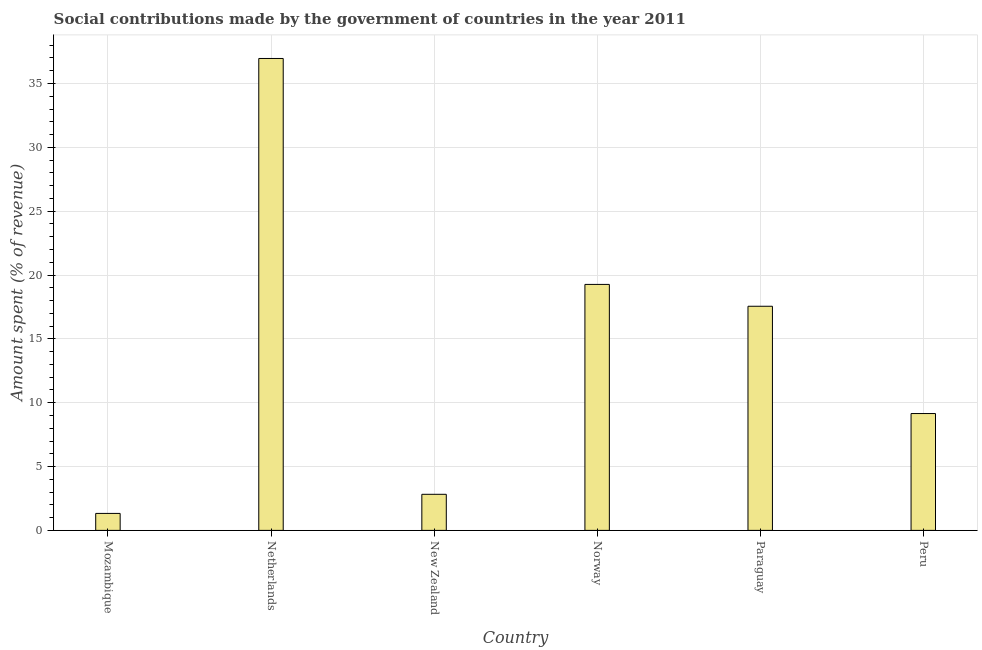What is the title of the graph?
Your answer should be very brief. Social contributions made by the government of countries in the year 2011. What is the label or title of the X-axis?
Your answer should be very brief. Country. What is the label or title of the Y-axis?
Keep it short and to the point. Amount spent (% of revenue). What is the amount spent in making social contributions in Netherlands?
Give a very brief answer. 36.96. Across all countries, what is the maximum amount spent in making social contributions?
Offer a terse response. 36.96. Across all countries, what is the minimum amount spent in making social contributions?
Provide a short and direct response. 1.33. In which country was the amount spent in making social contributions minimum?
Give a very brief answer. Mozambique. What is the sum of the amount spent in making social contributions?
Provide a short and direct response. 87.09. What is the difference between the amount spent in making social contributions in New Zealand and Norway?
Your answer should be very brief. -16.44. What is the average amount spent in making social contributions per country?
Offer a terse response. 14.52. What is the median amount spent in making social contributions?
Keep it short and to the point. 13.35. In how many countries, is the amount spent in making social contributions greater than 3 %?
Provide a succinct answer. 4. What is the ratio of the amount spent in making social contributions in Mozambique to that in Peru?
Make the answer very short. 0.14. Is the amount spent in making social contributions in Mozambique less than that in New Zealand?
Provide a short and direct response. Yes. Is the difference between the amount spent in making social contributions in New Zealand and Norway greater than the difference between any two countries?
Keep it short and to the point. No. What is the difference between the highest and the second highest amount spent in making social contributions?
Your answer should be very brief. 17.7. Is the sum of the amount spent in making social contributions in Norway and Paraguay greater than the maximum amount spent in making social contributions across all countries?
Offer a terse response. No. What is the difference between the highest and the lowest amount spent in making social contributions?
Give a very brief answer. 35.63. Are all the bars in the graph horizontal?
Offer a very short reply. No. How many countries are there in the graph?
Provide a succinct answer. 6. Are the values on the major ticks of Y-axis written in scientific E-notation?
Your answer should be compact. No. What is the Amount spent (% of revenue) of Mozambique?
Your answer should be compact. 1.33. What is the Amount spent (% of revenue) in Netherlands?
Make the answer very short. 36.96. What is the Amount spent (% of revenue) of New Zealand?
Give a very brief answer. 2.83. What is the Amount spent (% of revenue) of Norway?
Your response must be concise. 19.27. What is the Amount spent (% of revenue) in Paraguay?
Your answer should be compact. 17.55. What is the Amount spent (% of revenue) in Peru?
Offer a very short reply. 9.15. What is the difference between the Amount spent (% of revenue) in Mozambique and Netherlands?
Your answer should be compact. -35.63. What is the difference between the Amount spent (% of revenue) in Mozambique and New Zealand?
Offer a very short reply. -1.5. What is the difference between the Amount spent (% of revenue) in Mozambique and Norway?
Your answer should be very brief. -17.94. What is the difference between the Amount spent (% of revenue) in Mozambique and Paraguay?
Provide a succinct answer. -16.23. What is the difference between the Amount spent (% of revenue) in Mozambique and Peru?
Ensure brevity in your answer.  -7.82. What is the difference between the Amount spent (% of revenue) in Netherlands and New Zealand?
Your response must be concise. 34.14. What is the difference between the Amount spent (% of revenue) in Netherlands and Norway?
Offer a terse response. 17.7. What is the difference between the Amount spent (% of revenue) in Netherlands and Paraguay?
Offer a very short reply. 19.41. What is the difference between the Amount spent (% of revenue) in Netherlands and Peru?
Provide a short and direct response. 27.81. What is the difference between the Amount spent (% of revenue) in New Zealand and Norway?
Your answer should be very brief. -16.44. What is the difference between the Amount spent (% of revenue) in New Zealand and Paraguay?
Ensure brevity in your answer.  -14.73. What is the difference between the Amount spent (% of revenue) in New Zealand and Peru?
Provide a succinct answer. -6.33. What is the difference between the Amount spent (% of revenue) in Norway and Paraguay?
Offer a very short reply. 1.71. What is the difference between the Amount spent (% of revenue) in Norway and Peru?
Your answer should be very brief. 10.11. What is the difference between the Amount spent (% of revenue) in Paraguay and Peru?
Provide a short and direct response. 8.4. What is the ratio of the Amount spent (% of revenue) in Mozambique to that in Netherlands?
Make the answer very short. 0.04. What is the ratio of the Amount spent (% of revenue) in Mozambique to that in New Zealand?
Offer a terse response. 0.47. What is the ratio of the Amount spent (% of revenue) in Mozambique to that in Norway?
Give a very brief answer. 0.07. What is the ratio of the Amount spent (% of revenue) in Mozambique to that in Paraguay?
Your answer should be very brief. 0.08. What is the ratio of the Amount spent (% of revenue) in Mozambique to that in Peru?
Offer a very short reply. 0.14. What is the ratio of the Amount spent (% of revenue) in Netherlands to that in New Zealand?
Your answer should be compact. 13.08. What is the ratio of the Amount spent (% of revenue) in Netherlands to that in Norway?
Your answer should be very brief. 1.92. What is the ratio of the Amount spent (% of revenue) in Netherlands to that in Paraguay?
Your response must be concise. 2.11. What is the ratio of the Amount spent (% of revenue) in Netherlands to that in Peru?
Make the answer very short. 4.04. What is the ratio of the Amount spent (% of revenue) in New Zealand to that in Norway?
Offer a terse response. 0.15. What is the ratio of the Amount spent (% of revenue) in New Zealand to that in Paraguay?
Give a very brief answer. 0.16. What is the ratio of the Amount spent (% of revenue) in New Zealand to that in Peru?
Offer a very short reply. 0.31. What is the ratio of the Amount spent (% of revenue) in Norway to that in Paraguay?
Give a very brief answer. 1.1. What is the ratio of the Amount spent (% of revenue) in Norway to that in Peru?
Offer a terse response. 2.1. What is the ratio of the Amount spent (% of revenue) in Paraguay to that in Peru?
Your response must be concise. 1.92. 